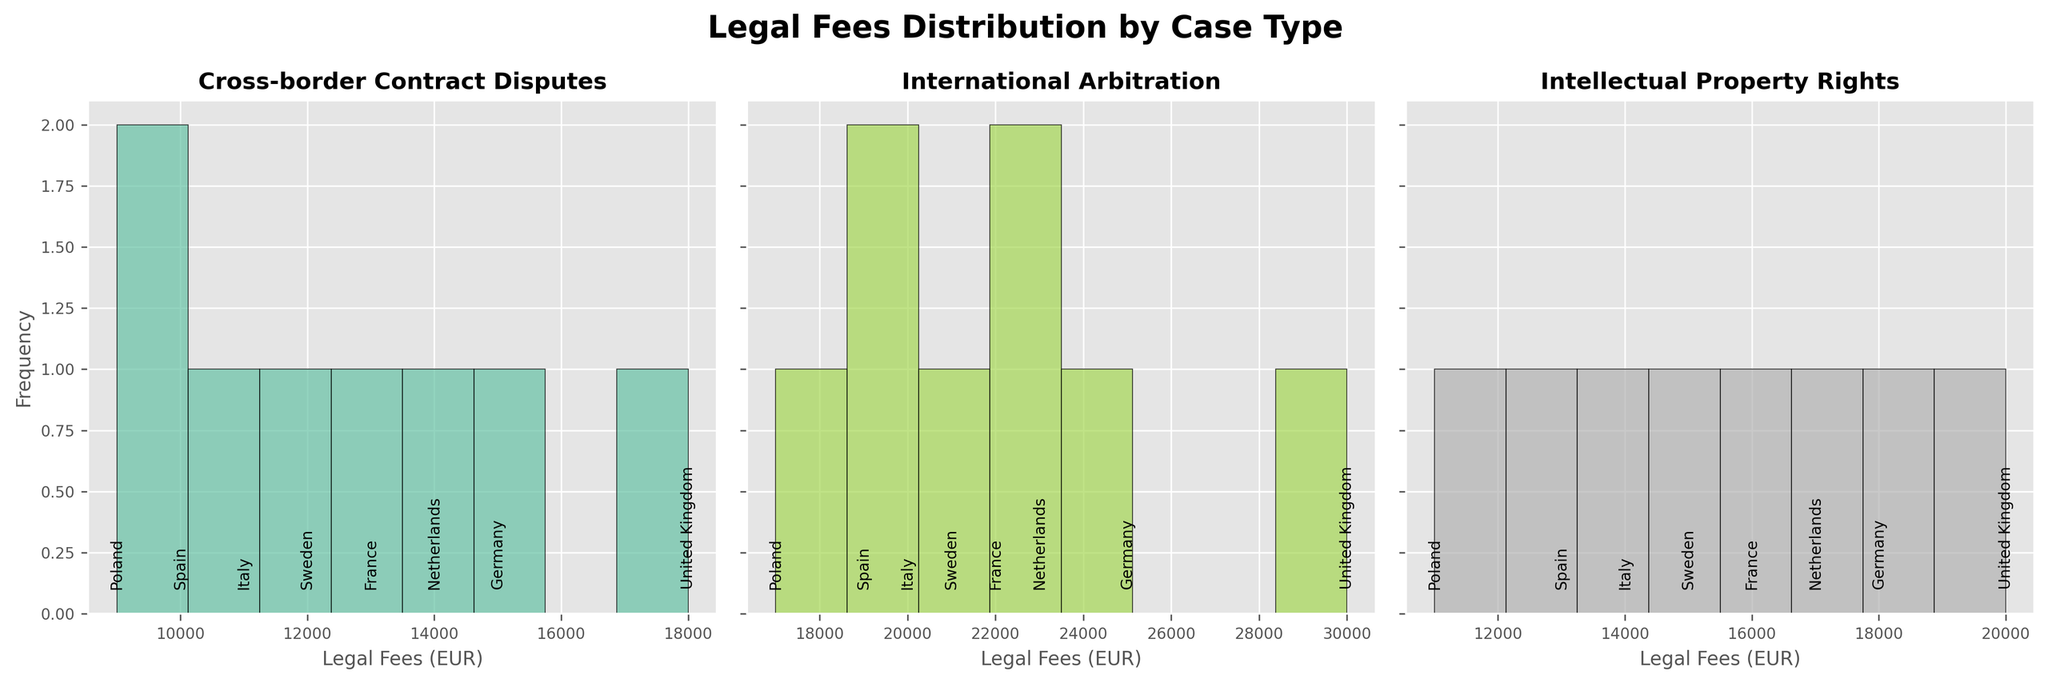What is the title of the figure? The title of the figure is located at the top of the plot. It provides an overview of what the figure is about.
Answer: Legal Fees Distribution by Case Type Which case type appears to have the highest frequency of legal fees in the €10,000 to €15,000 range? To determine this, observe the histogram bars in each subplot and identify which one has the highest bar in the €10,000 to €15,000 range.
Answer: Cross-border Contract Disputes In which case type and corresponding legal fees is France represented the highest? Scan through each subplot and look for the label "France"; compare the respective bar heights. The highest bar indicates the highest representation.
Answer: International Arbitration, €22,000 Compare the average legal fees for International Arbitration and Intellectual Property Rights. Which one has a higher average? Calculate the average legal fees for each case type by summing up the legal fees and dividing by the number of countries. International Arbitration: (25000 + 22000 + 30000 + 23000 + 21000 + 20000 + 19000 + 17000)/8 = 22125. Intellectual Property Rights: (18000 + 16000 + 20000 + 17000 + 15000 + 14000 + 13000 + 11000)/8 = 15375.
Answer: International Arbitration Which country has the lowest legal fees for Cross-border Contract Disputes? Check the "Cross-border Contract Disputes" subplot, find the lowest bar, and note the associated country label.
Answer: Poland What is the range of legal fees for Cross-border Contract Disputes? Identify the minimum and maximum legal fees in the "Cross-border Contract Disputes" subplot and subtract the minimum from the maximum. Minimum: €9000 (Poland), Maximum: €18000 (United Kingdom). Range = €18000 - €9000.
Answer: €9000 Based on the plots, which case type appears to be the most evenly distributed among the countries? Examine each subplot and observe the variability in bar heights. The most evenly distributed one will have bars of similar height.
Answer: Cross-border Contract Disputes Which country has the highest legal fees for Intellectual Property Rights cases? In the "Intellectual Property Rights" subplot, find the tallest bar and read the country label associated with it.
Answer: United Kingdom Between Sweden and Italy, which country has higher legal fees for International Arbitration cases? Look at the bars labeled "Sweden" and "Italy" in the "International Arbitration" subplot and compare their heights.
Answer: Sweden What are the legal fees for Germany across all case types? Check each subplot for the bars labeled "Germany" and note the legal fees. Sum them up. Cross-border Contract Disputes: €15000, International Arbitration: €25000, Intellectual Property Rights: €18000. Total = 15000 + 25000 + 18000.
Answer: €58000 